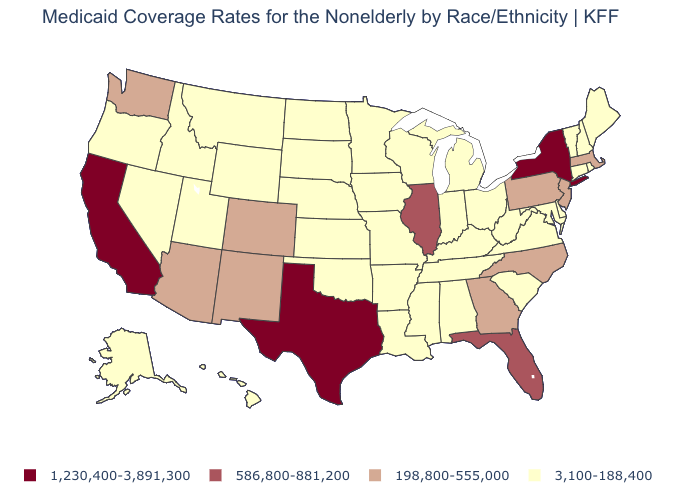Does Florida have a higher value than Illinois?
Concise answer only. No. Does the first symbol in the legend represent the smallest category?
Answer briefly. No. Which states have the lowest value in the USA?
Concise answer only. Alabama, Alaska, Arkansas, Connecticut, Delaware, Hawaii, Idaho, Indiana, Iowa, Kansas, Kentucky, Louisiana, Maine, Maryland, Michigan, Minnesota, Mississippi, Missouri, Montana, Nebraska, Nevada, New Hampshire, North Dakota, Ohio, Oklahoma, Oregon, Rhode Island, South Carolina, South Dakota, Tennessee, Utah, Vermont, Virginia, West Virginia, Wisconsin, Wyoming. Is the legend a continuous bar?
Write a very short answer. No. Which states hav the highest value in the West?
Concise answer only. California. Which states hav the highest value in the Northeast?
Write a very short answer. New York. Does New Mexico have a higher value than Georgia?
Be succinct. No. Does Washington have the lowest value in the USA?
Write a very short answer. No. Which states have the highest value in the USA?
Quick response, please. California, New York, Texas. Does Montana have the same value as Indiana?
Short answer required. Yes. Name the states that have a value in the range 198,800-555,000?
Write a very short answer. Arizona, Colorado, Georgia, Massachusetts, New Jersey, New Mexico, North Carolina, Pennsylvania, Washington. What is the value of Oklahoma?
Keep it brief. 3,100-188,400. What is the value of North Dakota?
Answer briefly. 3,100-188,400. Name the states that have a value in the range 586,800-881,200?
Concise answer only. Florida, Illinois. What is the value of Indiana?
Concise answer only. 3,100-188,400. 